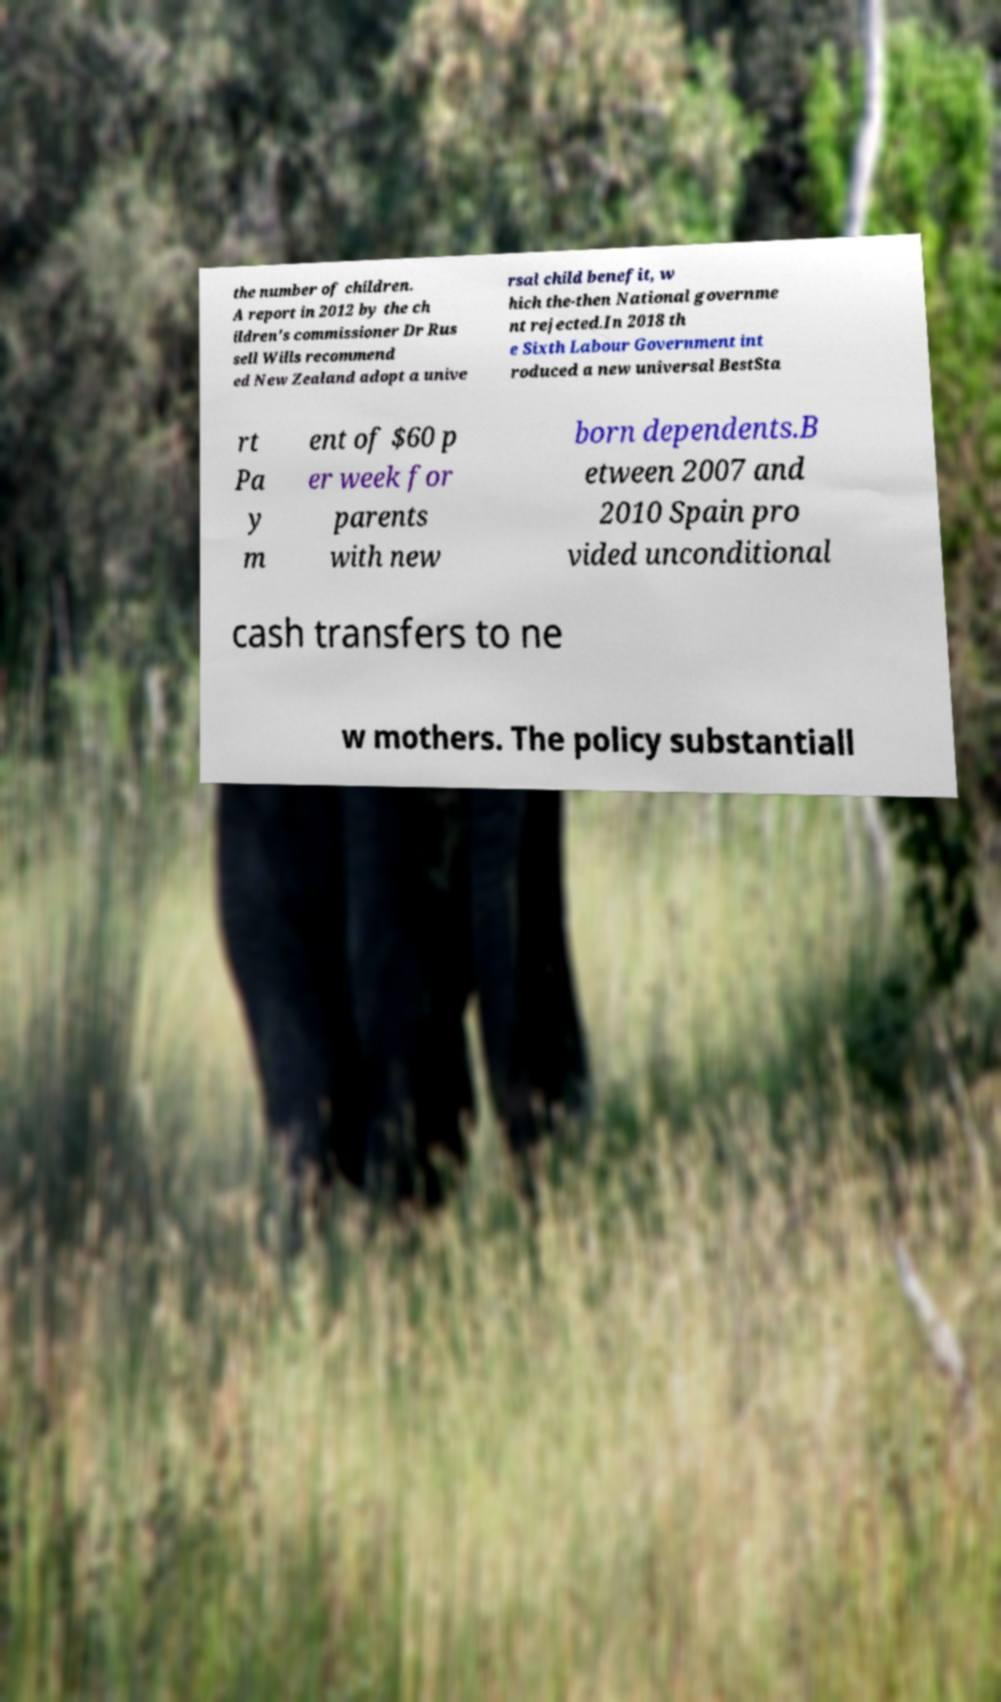I need the written content from this picture converted into text. Can you do that? the number of children. A report in 2012 by the ch ildren's commissioner Dr Rus sell Wills recommend ed New Zealand adopt a unive rsal child benefit, w hich the-then National governme nt rejected.In 2018 th e Sixth Labour Government int roduced a new universal BestSta rt Pa y m ent of $60 p er week for parents with new born dependents.B etween 2007 and 2010 Spain pro vided unconditional cash transfers to ne w mothers. The policy substantiall 